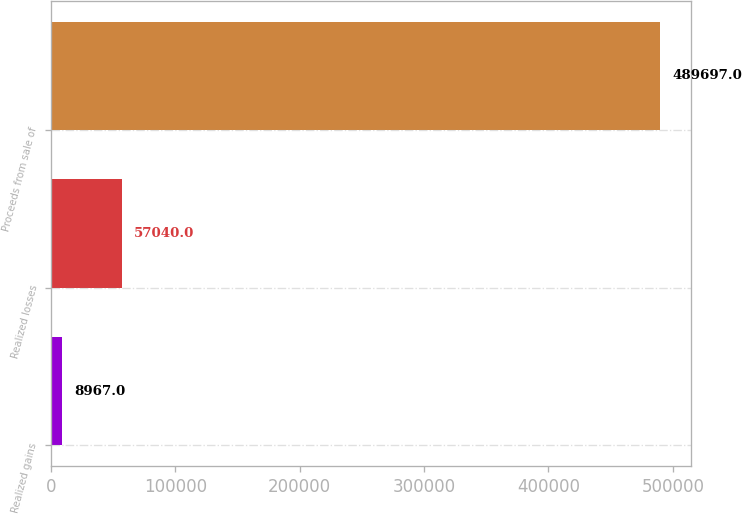<chart> <loc_0><loc_0><loc_500><loc_500><bar_chart><fcel>Realized gains<fcel>Realized losses<fcel>Proceeds from sale of<nl><fcel>8967<fcel>57040<fcel>489697<nl></chart> 